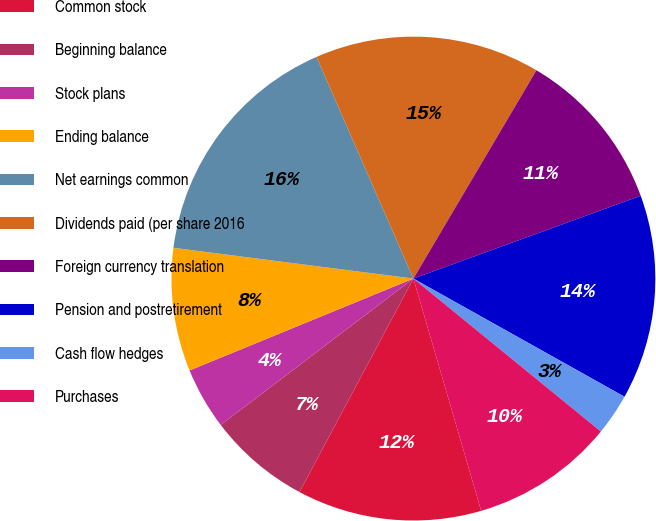Convert chart. <chart><loc_0><loc_0><loc_500><loc_500><pie_chart><fcel>Common stock<fcel>Beginning balance<fcel>Stock plans<fcel>Ending balance<fcel>Net earnings common<fcel>Dividends paid (per share 2016<fcel>Foreign currency translation<fcel>Pension and postretirement<fcel>Cash flow hedges<fcel>Purchases<nl><fcel>12.32%<fcel>6.86%<fcel>4.14%<fcel>8.23%<fcel>16.41%<fcel>15.05%<fcel>10.95%<fcel>13.68%<fcel>2.77%<fcel>9.59%<nl></chart> 